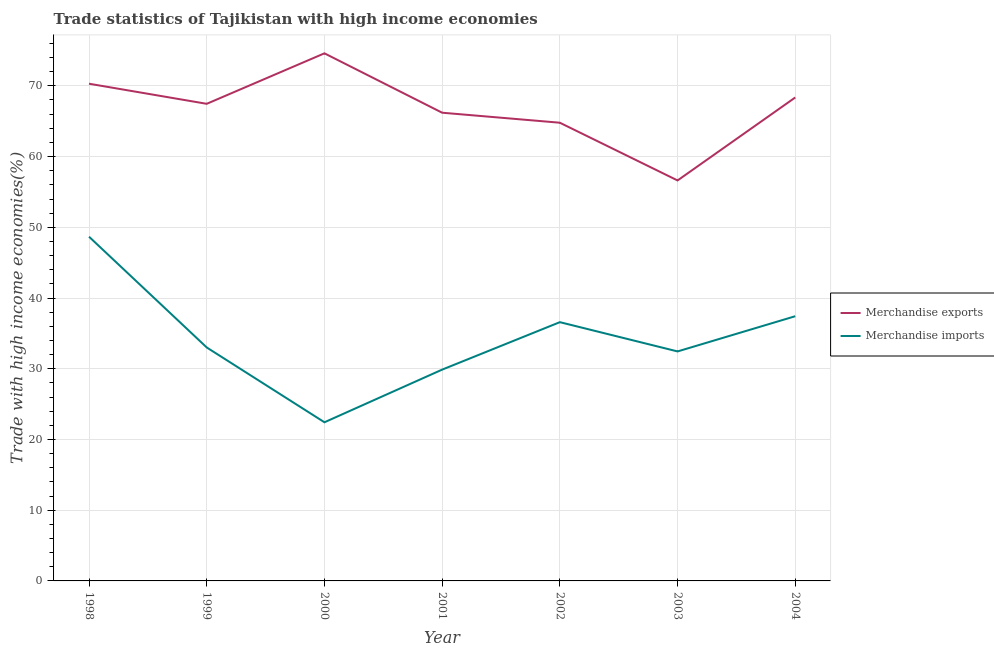How many different coloured lines are there?
Offer a terse response. 2. Is the number of lines equal to the number of legend labels?
Your answer should be very brief. Yes. What is the merchandise imports in 2001?
Give a very brief answer. 29.88. Across all years, what is the maximum merchandise imports?
Provide a short and direct response. 48.67. Across all years, what is the minimum merchandise exports?
Your answer should be very brief. 56.62. What is the total merchandise exports in the graph?
Make the answer very short. 468.32. What is the difference between the merchandise imports in 2001 and that in 2003?
Offer a very short reply. -2.57. What is the difference between the merchandise exports in 1998 and the merchandise imports in 2002?
Give a very brief answer. 33.71. What is the average merchandise exports per year?
Ensure brevity in your answer.  66.9. In the year 2003, what is the difference between the merchandise imports and merchandise exports?
Offer a terse response. -24.18. What is the ratio of the merchandise exports in 1998 to that in 2001?
Give a very brief answer. 1.06. Is the difference between the merchandise imports in 1999 and 2004 greater than the difference between the merchandise exports in 1999 and 2004?
Your answer should be very brief. No. What is the difference between the highest and the second highest merchandise imports?
Offer a very short reply. 11.24. What is the difference between the highest and the lowest merchandise imports?
Ensure brevity in your answer.  26.24. In how many years, is the merchandise imports greater than the average merchandise imports taken over all years?
Provide a short and direct response. 3. Does the merchandise imports monotonically increase over the years?
Keep it short and to the point. No. Is the merchandise imports strictly less than the merchandise exports over the years?
Offer a terse response. Yes. How many lines are there?
Your answer should be very brief. 2. How many years are there in the graph?
Provide a succinct answer. 7. What is the difference between two consecutive major ticks on the Y-axis?
Your response must be concise. 10. Are the values on the major ticks of Y-axis written in scientific E-notation?
Keep it short and to the point. No. Does the graph contain any zero values?
Make the answer very short. No. How many legend labels are there?
Make the answer very short. 2. What is the title of the graph?
Offer a terse response. Trade statistics of Tajikistan with high income economies. What is the label or title of the Y-axis?
Keep it short and to the point. Trade with high income economies(%). What is the Trade with high income economies(%) in Merchandise exports in 1998?
Make the answer very short. 70.3. What is the Trade with high income economies(%) in Merchandise imports in 1998?
Provide a succinct answer. 48.67. What is the Trade with high income economies(%) in Merchandise exports in 1999?
Your answer should be very brief. 67.46. What is the Trade with high income economies(%) of Merchandise imports in 1999?
Offer a very short reply. 33.01. What is the Trade with high income economies(%) in Merchandise exports in 2000?
Your answer should be very brief. 74.6. What is the Trade with high income economies(%) of Merchandise imports in 2000?
Your answer should be compact. 22.43. What is the Trade with high income economies(%) in Merchandise exports in 2001?
Keep it short and to the point. 66.2. What is the Trade with high income economies(%) of Merchandise imports in 2001?
Offer a very short reply. 29.88. What is the Trade with high income economies(%) of Merchandise exports in 2002?
Give a very brief answer. 64.78. What is the Trade with high income economies(%) in Merchandise imports in 2002?
Offer a terse response. 36.59. What is the Trade with high income economies(%) in Merchandise exports in 2003?
Give a very brief answer. 56.62. What is the Trade with high income economies(%) of Merchandise imports in 2003?
Provide a succinct answer. 32.45. What is the Trade with high income economies(%) in Merchandise exports in 2004?
Your answer should be very brief. 68.36. What is the Trade with high income economies(%) in Merchandise imports in 2004?
Ensure brevity in your answer.  37.43. Across all years, what is the maximum Trade with high income economies(%) in Merchandise exports?
Your answer should be very brief. 74.6. Across all years, what is the maximum Trade with high income economies(%) in Merchandise imports?
Your answer should be very brief. 48.67. Across all years, what is the minimum Trade with high income economies(%) of Merchandise exports?
Provide a succinct answer. 56.62. Across all years, what is the minimum Trade with high income economies(%) of Merchandise imports?
Your answer should be compact. 22.43. What is the total Trade with high income economies(%) of Merchandise exports in the graph?
Make the answer very short. 468.32. What is the total Trade with high income economies(%) of Merchandise imports in the graph?
Provide a succinct answer. 240.45. What is the difference between the Trade with high income economies(%) in Merchandise exports in 1998 and that in 1999?
Offer a very short reply. 2.84. What is the difference between the Trade with high income economies(%) in Merchandise imports in 1998 and that in 1999?
Offer a very short reply. 15.66. What is the difference between the Trade with high income economies(%) in Merchandise exports in 1998 and that in 2000?
Offer a very short reply. -4.3. What is the difference between the Trade with high income economies(%) of Merchandise imports in 1998 and that in 2000?
Your answer should be very brief. 26.24. What is the difference between the Trade with high income economies(%) of Merchandise exports in 1998 and that in 2001?
Keep it short and to the point. 4.1. What is the difference between the Trade with high income economies(%) of Merchandise imports in 1998 and that in 2001?
Ensure brevity in your answer.  18.79. What is the difference between the Trade with high income economies(%) of Merchandise exports in 1998 and that in 2002?
Ensure brevity in your answer.  5.51. What is the difference between the Trade with high income economies(%) in Merchandise imports in 1998 and that in 2002?
Offer a terse response. 12.08. What is the difference between the Trade with high income economies(%) in Merchandise exports in 1998 and that in 2003?
Keep it short and to the point. 13.68. What is the difference between the Trade with high income economies(%) in Merchandise imports in 1998 and that in 2003?
Ensure brevity in your answer.  16.22. What is the difference between the Trade with high income economies(%) of Merchandise exports in 1998 and that in 2004?
Your answer should be very brief. 1.94. What is the difference between the Trade with high income economies(%) of Merchandise imports in 1998 and that in 2004?
Give a very brief answer. 11.24. What is the difference between the Trade with high income economies(%) in Merchandise exports in 1999 and that in 2000?
Your answer should be compact. -7.14. What is the difference between the Trade with high income economies(%) in Merchandise imports in 1999 and that in 2000?
Offer a very short reply. 10.58. What is the difference between the Trade with high income economies(%) of Merchandise exports in 1999 and that in 2001?
Provide a succinct answer. 1.26. What is the difference between the Trade with high income economies(%) in Merchandise imports in 1999 and that in 2001?
Give a very brief answer. 3.13. What is the difference between the Trade with high income economies(%) of Merchandise exports in 1999 and that in 2002?
Your answer should be very brief. 2.67. What is the difference between the Trade with high income economies(%) in Merchandise imports in 1999 and that in 2002?
Your answer should be compact. -3.58. What is the difference between the Trade with high income economies(%) in Merchandise exports in 1999 and that in 2003?
Keep it short and to the point. 10.84. What is the difference between the Trade with high income economies(%) of Merchandise imports in 1999 and that in 2003?
Make the answer very short. 0.56. What is the difference between the Trade with high income economies(%) of Merchandise exports in 1999 and that in 2004?
Make the answer very short. -0.9. What is the difference between the Trade with high income economies(%) in Merchandise imports in 1999 and that in 2004?
Provide a succinct answer. -4.42. What is the difference between the Trade with high income economies(%) of Merchandise exports in 2000 and that in 2001?
Give a very brief answer. 8.4. What is the difference between the Trade with high income economies(%) of Merchandise imports in 2000 and that in 2001?
Keep it short and to the point. -7.44. What is the difference between the Trade with high income economies(%) of Merchandise exports in 2000 and that in 2002?
Provide a succinct answer. 9.81. What is the difference between the Trade with high income economies(%) of Merchandise imports in 2000 and that in 2002?
Make the answer very short. -14.15. What is the difference between the Trade with high income economies(%) of Merchandise exports in 2000 and that in 2003?
Your answer should be very brief. 17.97. What is the difference between the Trade with high income economies(%) in Merchandise imports in 2000 and that in 2003?
Offer a very short reply. -10.02. What is the difference between the Trade with high income economies(%) in Merchandise exports in 2000 and that in 2004?
Ensure brevity in your answer.  6.24. What is the difference between the Trade with high income economies(%) of Merchandise imports in 2000 and that in 2004?
Your answer should be compact. -15. What is the difference between the Trade with high income economies(%) in Merchandise exports in 2001 and that in 2002?
Offer a very short reply. 1.42. What is the difference between the Trade with high income economies(%) of Merchandise imports in 2001 and that in 2002?
Your answer should be very brief. -6.71. What is the difference between the Trade with high income economies(%) of Merchandise exports in 2001 and that in 2003?
Your answer should be very brief. 9.58. What is the difference between the Trade with high income economies(%) of Merchandise imports in 2001 and that in 2003?
Your answer should be very brief. -2.57. What is the difference between the Trade with high income economies(%) in Merchandise exports in 2001 and that in 2004?
Provide a succinct answer. -2.16. What is the difference between the Trade with high income economies(%) of Merchandise imports in 2001 and that in 2004?
Ensure brevity in your answer.  -7.55. What is the difference between the Trade with high income economies(%) of Merchandise exports in 2002 and that in 2003?
Provide a short and direct response. 8.16. What is the difference between the Trade with high income economies(%) in Merchandise imports in 2002 and that in 2003?
Your response must be concise. 4.14. What is the difference between the Trade with high income economies(%) of Merchandise exports in 2002 and that in 2004?
Keep it short and to the point. -3.57. What is the difference between the Trade with high income economies(%) of Merchandise imports in 2002 and that in 2004?
Your answer should be very brief. -0.84. What is the difference between the Trade with high income economies(%) of Merchandise exports in 2003 and that in 2004?
Ensure brevity in your answer.  -11.73. What is the difference between the Trade with high income economies(%) of Merchandise imports in 2003 and that in 2004?
Make the answer very short. -4.98. What is the difference between the Trade with high income economies(%) in Merchandise exports in 1998 and the Trade with high income economies(%) in Merchandise imports in 1999?
Give a very brief answer. 37.29. What is the difference between the Trade with high income economies(%) in Merchandise exports in 1998 and the Trade with high income economies(%) in Merchandise imports in 2000?
Offer a very short reply. 47.87. What is the difference between the Trade with high income economies(%) in Merchandise exports in 1998 and the Trade with high income economies(%) in Merchandise imports in 2001?
Provide a short and direct response. 40.42. What is the difference between the Trade with high income economies(%) of Merchandise exports in 1998 and the Trade with high income economies(%) of Merchandise imports in 2002?
Make the answer very short. 33.71. What is the difference between the Trade with high income economies(%) in Merchandise exports in 1998 and the Trade with high income economies(%) in Merchandise imports in 2003?
Keep it short and to the point. 37.85. What is the difference between the Trade with high income economies(%) of Merchandise exports in 1998 and the Trade with high income economies(%) of Merchandise imports in 2004?
Keep it short and to the point. 32.87. What is the difference between the Trade with high income economies(%) of Merchandise exports in 1999 and the Trade with high income economies(%) of Merchandise imports in 2000?
Keep it short and to the point. 45.03. What is the difference between the Trade with high income economies(%) in Merchandise exports in 1999 and the Trade with high income economies(%) in Merchandise imports in 2001?
Provide a short and direct response. 37.58. What is the difference between the Trade with high income economies(%) of Merchandise exports in 1999 and the Trade with high income economies(%) of Merchandise imports in 2002?
Your answer should be compact. 30.87. What is the difference between the Trade with high income economies(%) in Merchandise exports in 1999 and the Trade with high income economies(%) in Merchandise imports in 2003?
Offer a very short reply. 35.01. What is the difference between the Trade with high income economies(%) in Merchandise exports in 1999 and the Trade with high income economies(%) in Merchandise imports in 2004?
Give a very brief answer. 30.03. What is the difference between the Trade with high income economies(%) of Merchandise exports in 2000 and the Trade with high income economies(%) of Merchandise imports in 2001?
Provide a short and direct response. 44.72. What is the difference between the Trade with high income economies(%) in Merchandise exports in 2000 and the Trade with high income economies(%) in Merchandise imports in 2002?
Offer a terse response. 38.01. What is the difference between the Trade with high income economies(%) of Merchandise exports in 2000 and the Trade with high income economies(%) of Merchandise imports in 2003?
Your response must be concise. 42.15. What is the difference between the Trade with high income economies(%) in Merchandise exports in 2000 and the Trade with high income economies(%) in Merchandise imports in 2004?
Ensure brevity in your answer.  37.17. What is the difference between the Trade with high income economies(%) of Merchandise exports in 2001 and the Trade with high income economies(%) of Merchandise imports in 2002?
Your answer should be compact. 29.61. What is the difference between the Trade with high income economies(%) of Merchandise exports in 2001 and the Trade with high income economies(%) of Merchandise imports in 2003?
Your answer should be very brief. 33.75. What is the difference between the Trade with high income economies(%) of Merchandise exports in 2001 and the Trade with high income economies(%) of Merchandise imports in 2004?
Ensure brevity in your answer.  28.77. What is the difference between the Trade with high income economies(%) in Merchandise exports in 2002 and the Trade with high income economies(%) in Merchandise imports in 2003?
Offer a terse response. 32.34. What is the difference between the Trade with high income economies(%) of Merchandise exports in 2002 and the Trade with high income economies(%) of Merchandise imports in 2004?
Keep it short and to the point. 27.36. What is the difference between the Trade with high income economies(%) in Merchandise exports in 2003 and the Trade with high income economies(%) in Merchandise imports in 2004?
Ensure brevity in your answer.  19.19. What is the average Trade with high income economies(%) in Merchandise exports per year?
Provide a succinct answer. 66.9. What is the average Trade with high income economies(%) in Merchandise imports per year?
Keep it short and to the point. 34.35. In the year 1998, what is the difference between the Trade with high income economies(%) in Merchandise exports and Trade with high income economies(%) in Merchandise imports?
Your response must be concise. 21.63. In the year 1999, what is the difference between the Trade with high income economies(%) of Merchandise exports and Trade with high income economies(%) of Merchandise imports?
Provide a short and direct response. 34.45. In the year 2000, what is the difference between the Trade with high income economies(%) in Merchandise exports and Trade with high income economies(%) in Merchandise imports?
Provide a short and direct response. 52.17. In the year 2001, what is the difference between the Trade with high income economies(%) of Merchandise exports and Trade with high income economies(%) of Merchandise imports?
Keep it short and to the point. 36.32. In the year 2002, what is the difference between the Trade with high income economies(%) in Merchandise exports and Trade with high income economies(%) in Merchandise imports?
Offer a terse response. 28.2. In the year 2003, what is the difference between the Trade with high income economies(%) of Merchandise exports and Trade with high income economies(%) of Merchandise imports?
Offer a very short reply. 24.18. In the year 2004, what is the difference between the Trade with high income economies(%) in Merchandise exports and Trade with high income economies(%) in Merchandise imports?
Provide a succinct answer. 30.93. What is the ratio of the Trade with high income economies(%) in Merchandise exports in 1998 to that in 1999?
Your answer should be compact. 1.04. What is the ratio of the Trade with high income economies(%) in Merchandise imports in 1998 to that in 1999?
Provide a succinct answer. 1.47. What is the ratio of the Trade with high income economies(%) in Merchandise exports in 1998 to that in 2000?
Make the answer very short. 0.94. What is the ratio of the Trade with high income economies(%) of Merchandise imports in 1998 to that in 2000?
Your answer should be very brief. 2.17. What is the ratio of the Trade with high income economies(%) in Merchandise exports in 1998 to that in 2001?
Your answer should be compact. 1.06. What is the ratio of the Trade with high income economies(%) in Merchandise imports in 1998 to that in 2001?
Your answer should be very brief. 1.63. What is the ratio of the Trade with high income economies(%) of Merchandise exports in 1998 to that in 2002?
Your answer should be very brief. 1.09. What is the ratio of the Trade with high income economies(%) of Merchandise imports in 1998 to that in 2002?
Your answer should be compact. 1.33. What is the ratio of the Trade with high income economies(%) in Merchandise exports in 1998 to that in 2003?
Make the answer very short. 1.24. What is the ratio of the Trade with high income economies(%) of Merchandise imports in 1998 to that in 2003?
Provide a succinct answer. 1.5. What is the ratio of the Trade with high income economies(%) of Merchandise exports in 1998 to that in 2004?
Offer a terse response. 1.03. What is the ratio of the Trade with high income economies(%) in Merchandise imports in 1998 to that in 2004?
Keep it short and to the point. 1.3. What is the ratio of the Trade with high income economies(%) of Merchandise exports in 1999 to that in 2000?
Keep it short and to the point. 0.9. What is the ratio of the Trade with high income economies(%) of Merchandise imports in 1999 to that in 2000?
Provide a succinct answer. 1.47. What is the ratio of the Trade with high income economies(%) in Merchandise exports in 1999 to that in 2001?
Your response must be concise. 1.02. What is the ratio of the Trade with high income economies(%) of Merchandise imports in 1999 to that in 2001?
Provide a succinct answer. 1.1. What is the ratio of the Trade with high income economies(%) in Merchandise exports in 1999 to that in 2002?
Your answer should be very brief. 1.04. What is the ratio of the Trade with high income economies(%) of Merchandise imports in 1999 to that in 2002?
Provide a succinct answer. 0.9. What is the ratio of the Trade with high income economies(%) in Merchandise exports in 1999 to that in 2003?
Keep it short and to the point. 1.19. What is the ratio of the Trade with high income economies(%) in Merchandise imports in 1999 to that in 2003?
Your answer should be very brief. 1.02. What is the ratio of the Trade with high income economies(%) of Merchandise exports in 1999 to that in 2004?
Ensure brevity in your answer.  0.99. What is the ratio of the Trade with high income economies(%) in Merchandise imports in 1999 to that in 2004?
Keep it short and to the point. 0.88. What is the ratio of the Trade with high income economies(%) of Merchandise exports in 2000 to that in 2001?
Your response must be concise. 1.13. What is the ratio of the Trade with high income economies(%) in Merchandise imports in 2000 to that in 2001?
Offer a terse response. 0.75. What is the ratio of the Trade with high income economies(%) in Merchandise exports in 2000 to that in 2002?
Your answer should be very brief. 1.15. What is the ratio of the Trade with high income economies(%) in Merchandise imports in 2000 to that in 2002?
Your response must be concise. 0.61. What is the ratio of the Trade with high income economies(%) of Merchandise exports in 2000 to that in 2003?
Give a very brief answer. 1.32. What is the ratio of the Trade with high income economies(%) of Merchandise imports in 2000 to that in 2003?
Provide a short and direct response. 0.69. What is the ratio of the Trade with high income economies(%) in Merchandise exports in 2000 to that in 2004?
Your response must be concise. 1.09. What is the ratio of the Trade with high income economies(%) of Merchandise imports in 2000 to that in 2004?
Offer a terse response. 0.6. What is the ratio of the Trade with high income economies(%) in Merchandise exports in 2001 to that in 2002?
Your response must be concise. 1.02. What is the ratio of the Trade with high income economies(%) in Merchandise imports in 2001 to that in 2002?
Provide a succinct answer. 0.82. What is the ratio of the Trade with high income economies(%) in Merchandise exports in 2001 to that in 2003?
Your answer should be very brief. 1.17. What is the ratio of the Trade with high income economies(%) of Merchandise imports in 2001 to that in 2003?
Offer a very short reply. 0.92. What is the ratio of the Trade with high income economies(%) in Merchandise exports in 2001 to that in 2004?
Keep it short and to the point. 0.97. What is the ratio of the Trade with high income economies(%) of Merchandise imports in 2001 to that in 2004?
Your answer should be compact. 0.8. What is the ratio of the Trade with high income economies(%) of Merchandise exports in 2002 to that in 2003?
Your answer should be very brief. 1.14. What is the ratio of the Trade with high income economies(%) in Merchandise imports in 2002 to that in 2003?
Give a very brief answer. 1.13. What is the ratio of the Trade with high income economies(%) of Merchandise exports in 2002 to that in 2004?
Provide a short and direct response. 0.95. What is the ratio of the Trade with high income economies(%) of Merchandise imports in 2002 to that in 2004?
Give a very brief answer. 0.98. What is the ratio of the Trade with high income economies(%) of Merchandise exports in 2003 to that in 2004?
Your answer should be very brief. 0.83. What is the ratio of the Trade with high income economies(%) of Merchandise imports in 2003 to that in 2004?
Your answer should be very brief. 0.87. What is the difference between the highest and the second highest Trade with high income economies(%) of Merchandise exports?
Provide a succinct answer. 4.3. What is the difference between the highest and the second highest Trade with high income economies(%) of Merchandise imports?
Offer a terse response. 11.24. What is the difference between the highest and the lowest Trade with high income economies(%) in Merchandise exports?
Offer a very short reply. 17.97. What is the difference between the highest and the lowest Trade with high income economies(%) of Merchandise imports?
Ensure brevity in your answer.  26.24. 